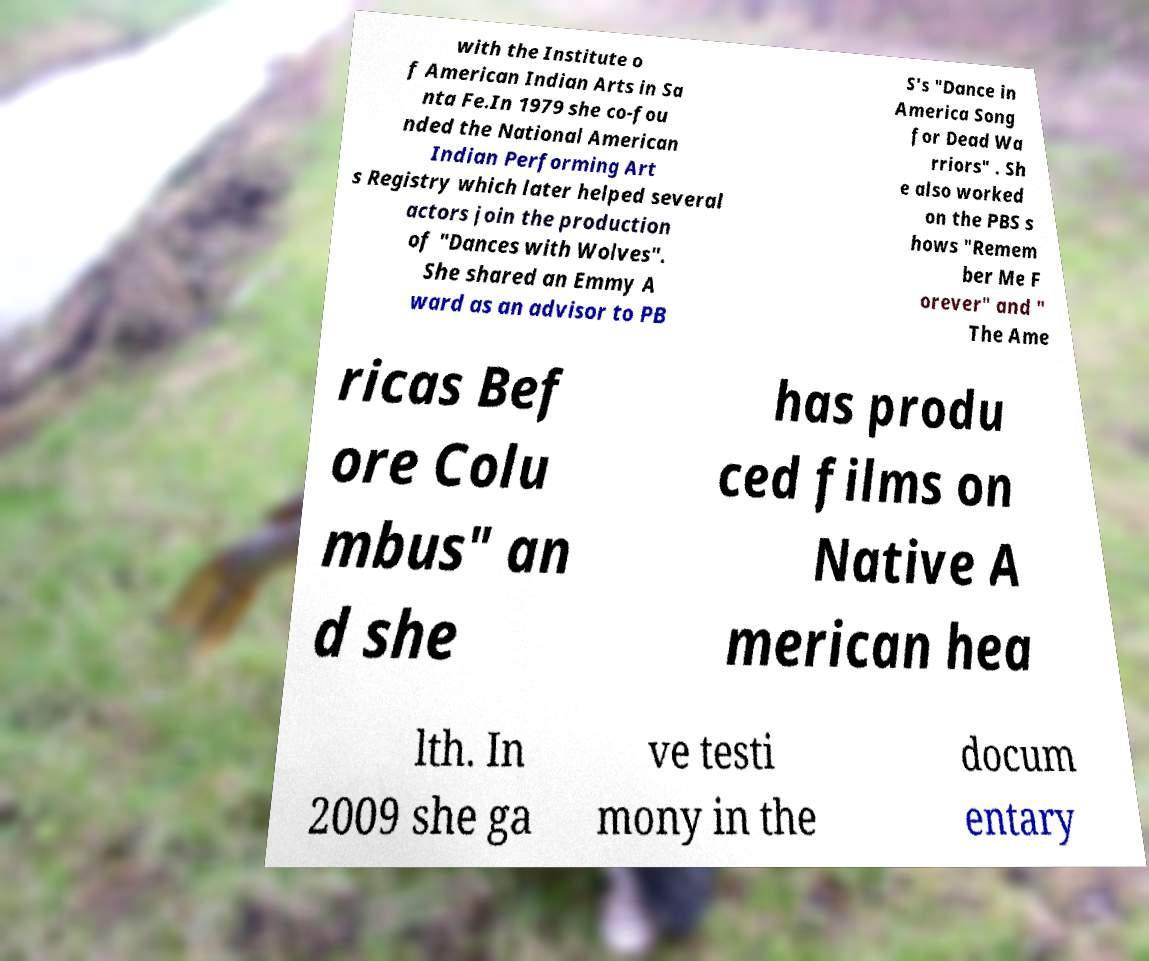Could you assist in decoding the text presented in this image and type it out clearly? with the Institute o f American Indian Arts in Sa nta Fe.In 1979 she co-fou nded the National American Indian Performing Art s Registry which later helped several actors join the production of "Dances with Wolves". She shared an Emmy A ward as an advisor to PB S's "Dance in America Song for Dead Wa rriors" . Sh e also worked on the PBS s hows "Remem ber Me F orever" and " The Ame ricas Bef ore Colu mbus" an d she has produ ced films on Native A merican hea lth. In 2009 she ga ve testi mony in the docum entary 